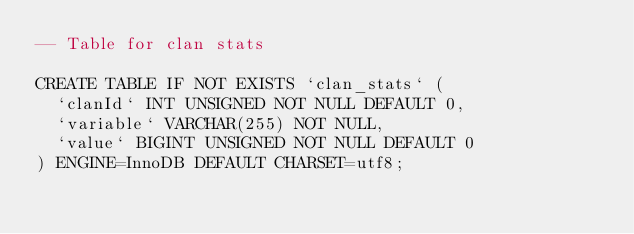<code> <loc_0><loc_0><loc_500><loc_500><_SQL_>-- Table for clan stats

CREATE TABLE IF NOT EXISTS `clan_stats` (
  `clanId` INT UNSIGNED NOT NULL DEFAULT 0,
  `variable` VARCHAR(255) NOT NULL,
  `value` BIGINT UNSIGNED NOT NULL DEFAULT 0
) ENGINE=InnoDB DEFAULT CHARSET=utf8;</code> 